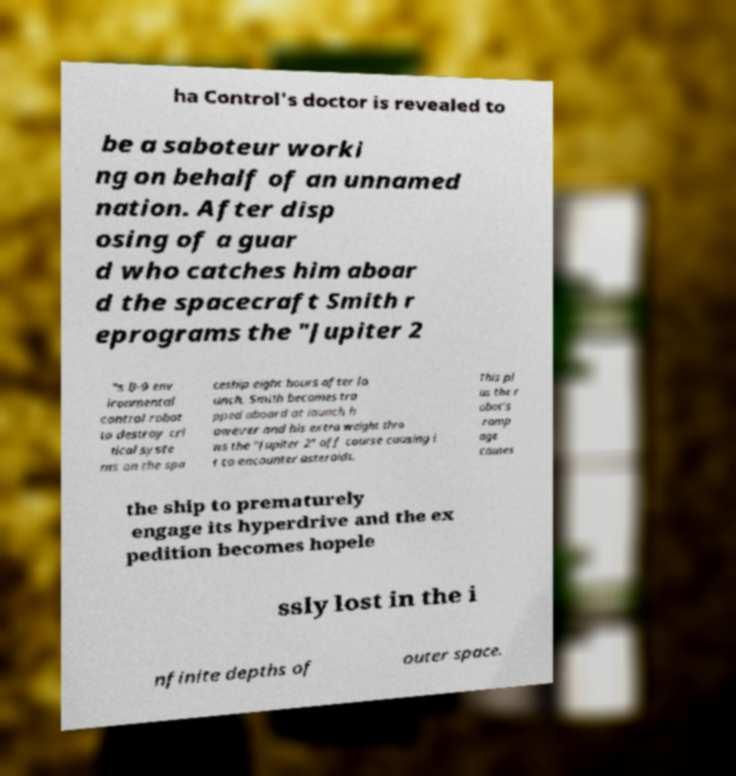Please read and relay the text visible in this image. What does it say? ha Control's doctor is revealed to be a saboteur worki ng on behalf of an unnamed nation. After disp osing of a guar d who catches him aboar d the spacecraft Smith r eprograms the "Jupiter 2 "s B-9 env ironmental control robot to destroy cri tical syste ms on the spa ceship eight hours after la unch. Smith becomes tra pped aboard at launch h owever and his extra weight thro ws the "Jupiter 2" off course causing i t to encounter asteroids. This pl us the r obot's ramp age causes the ship to prematurely engage its hyperdrive and the ex pedition becomes hopele ssly lost in the i nfinite depths of outer space. 